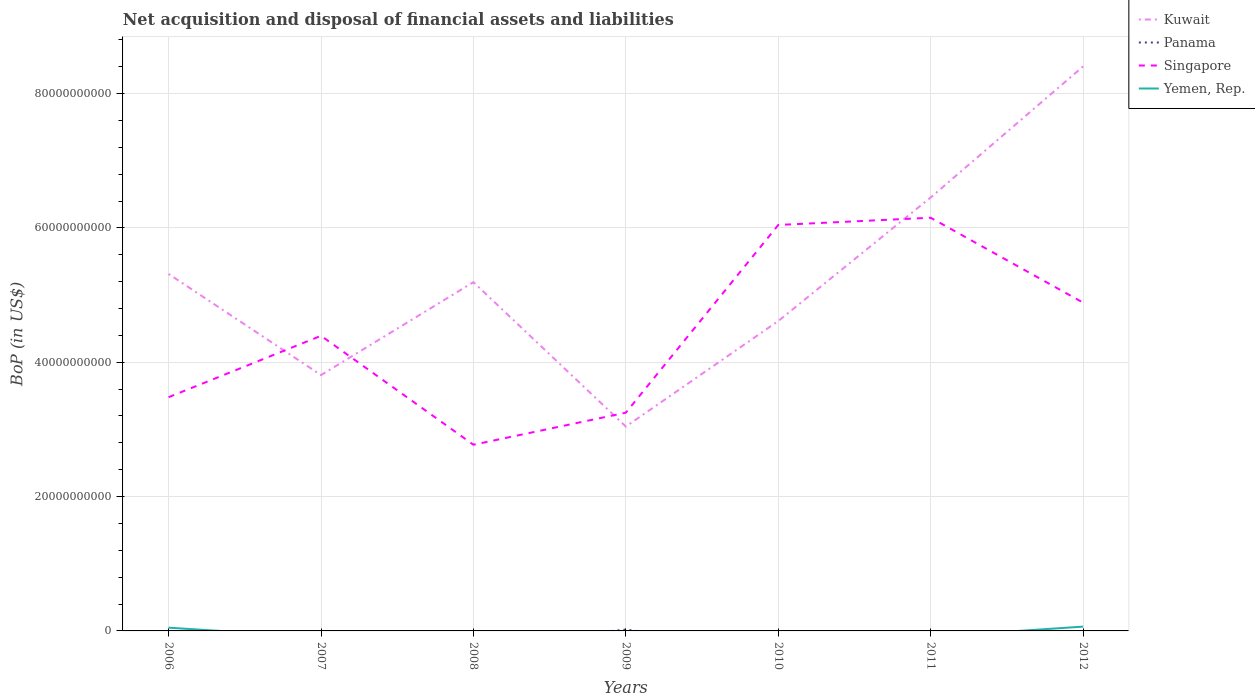How many different coloured lines are there?
Ensure brevity in your answer.  4. Does the line corresponding to Kuwait intersect with the line corresponding to Panama?
Your response must be concise. No. Across all years, what is the maximum Balance of Payments in Kuwait?
Provide a short and direct response. 3.04e+1. What is the total Balance of Payments in Kuwait in the graph?
Give a very brief answer. -3.21e+1. What is the difference between the highest and the second highest Balance of Payments in Yemen, Rep.?
Provide a succinct answer. 6.41e+08. How many lines are there?
Offer a terse response. 4. What is the difference between two consecutive major ticks on the Y-axis?
Ensure brevity in your answer.  2.00e+1. Are the values on the major ticks of Y-axis written in scientific E-notation?
Your answer should be compact. No. Does the graph contain any zero values?
Keep it short and to the point. Yes. What is the title of the graph?
Your answer should be compact. Net acquisition and disposal of financial assets and liabilities. Does "Ecuador" appear as one of the legend labels in the graph?
Ensure brevity in your answer.  No. What is the label or title of the Y-axis?
Provide a short and direct response. BoP (in US$). What is the BoP (in US$) in Kuwait in 2006?
Give a very brief answer. 5.31e+1. What is the BoP (in US$) of Panama in 2006?
Your answer should be compact. 0. What is the BoP (in US$) in Singapore in 2006?
Keep it short and to the point. 3.48e+1. What is the BoP (in US$) in Yemen, Rep. in 2006?
Offer a very short reply. 4.81e+08. What is the BoP (in US$) in Kuwait in 2007?
Your answer should be very brief. 3.81e+1. What is the BoP (in US$) of Singapore in 2007?
Provide a short and direct response. 4.39e+1. What is the BoP (in US$) in Yemen, Rep. in 2007?
Keep it short and to the point. 0. What is the BoP (in US$) of Kuwait in 2008?
Offer a very short reply. 5.19e+1. What is the BoP (in US$) of Singapore in 2008?
Give a very brief answer. 2.77e+1. What is the BoP (in US$) of Yemen, Rep. in 2008?
Offer a terse response. 0. What is the BoP (in US$) in Kuwait in 2009?
Keep it short and to the point. 3.04e+1. What is the BoP (in US$) in Panama in 2009?
Offer a very short reply. 2.02e+08. What is the BoP (in US$) in Singapore in 2009?
Provide a short and direct response. 3.25e+1. What is the BoP (in US$) of Yemen, Rep. in 2009?
Keep it short and to the point. 0. What is the BoP (in US$) in Kuwait in 2010?
Your answer should be very brief. 4.61e+1. What is the BoP (in US$) of Singapore in 2010?
Ensure brevity in your answer.  6.04e+1. What is the BoP (in US$) of Kuwait in 2011?
Your answer should be compact. 6.45e+1. What is the BoP (in US$) of Panama in 2011?
Make the answer very short. 0. What is the BoP (in US$) in Singapore in 2011?
Your response must be concise. 6.15e+1. What is the BoP (in US$) in Yemen, Rep. in 2011?
Offer a terse response. 0. What is the BoP (in US$) in Kuwait in 2012?
Keep it short and to the point. 8.40e+1. What is the BoP (in US$) in Panama in 2012?
Make the answer very short. 0. What is the BoP (in US$) of Singapore in 2012?
Ensure brevity in your answer.  4.89e+1. What is the BoP (in US$) in Yemen, Rep. in 2012?
Give a very brief answer. 6.41e+08. Across all years, what is the maximum BoP (in US$) of Kuwait?
Your answer should be compact. 8.40e+1. Across all years, what is the maximum BoP (in US$) in Panama?
Your response must be concise. 2.02e+08. Across all years, what is the maximum BoP (in US$) of Singapore?
Your answer should be compact. 6.15e+1. Across all years, what is the maximum BoP (in US$) in Yemen, Rep.?
Provide a short and direct response. 6.41e+08. Across all years, what is the minimum BoP (in US$) in Kuwait?
Offer a very short reply. 3.04e+1. Across all years, what is the minimum BoP (in US$) of Panama?
Ensure brevity in your answer.  0. Across all years, what is the minimum BoP (in US$) in Singapore?
Offer a very short reply. 2.77e+1. What is the total BoP (in US$) of Kuwait in the graph?
Your answer should be very brief. 3.68e+11. What is the total BoP (in US$) in Panama in the graph?
Make the answer very short. 2.02e+08. What is the total BoP (in US$) in Singapore in the graph?
Provide a succinct answer. 3.10e+11. What is the total BoP (in US$) of Yemen, Rep. in the graph?
Provide a succinct answer. 1.12e+09. What is the difference between the BoP (in US$) of Kuwait in 2006 and that in 2007?
Provide a succinct answer. 1.51e+1. What is the difference between the BoP (in US$) in Singapore in 2006 and that in 2007?
Offer a very short reply. -9.14e+09. What is the difference between the BoP (in US$) in Kuwait in 2006 and that in 2008?
Offer a terse response. 1.22e+09. What is the difference between the BoP (in US$) in Singapore in 2006 and that in 2008?
Your answer should be very brief. 7.08e+09. What is the difference between the BoP (in US$) of Kuwait in 2006 and that in 2009?
Your answer should be compact. 2.27e+1. What is the difference between the BoP (in US$) of Singapore in 2006 and that in 2009?
Provide a short and direct response. 2.31e+09. What is the difference between the BoP (in US$) of Kuwait in 2006 and that in 2010?
Offer a very short reply. 7.01e+09. What is the difference between the BoP (in US$) in Singapore in 2006 and that in 2010?
Provide a short and direct response. -2.56e+1. What is the difference between the BoP (in US$) in Kuwait in 2006 and that in 2011?
Provide a short and direct response. -1.14e+1. What is the difference between the BoP (in US$) in Singapore in 2006 and that in 2011?
Give a very brief answer. -2.67e+1. What is the difference between the BoP (in US$) of Kuwait in 2006 and that in 2012?
Provide a short and direct response. -3.09e+1. What is the difference between the BoP (in US$) of Singapore in 2006 and that in 2012?
Ensure brevity in your answer.  -1.41e+1. What is the difference between the BoP (in US$) in Yemen, Rep. in 2006 and that in 2012?
Your answer should be very brief. -1.59e+08. What is the difference between the BoP (in US$) of Kuwait in 2007 and that in 2008?
Your answer should be compact. -1.38e+1. What is the difference between the BoP (in US$) of Singapore in 2007 and that in 2008?
Your answer should be very brief. 1.62e+1. What is the difference between the BoP (in US$) in Kuwait in 2007 and that in 2009?
Provide a succinct answer. 7.66e+09. What is the difference between the BoP (in US$) in Singapore in 2007 and that in 2009?
Provide a succinct answer. 1.14e+1. What is the difference between the BoP (in US$) of Kuwait in 2007 and that in 2010?
Your answer should be compact. -8.05e+09. What is the difference between the BoP (in US$) of Singapore in 2007 and that in 2010?
Keep it short and to the point. -1.65e+1. What is the difference between the BoP (in US$) in Kuwait in 2007 and that in 2011?
Provide a succinct answer. -2.64e+1. What is the difference between the BoP (in US$) of Singapore in 2007 and that in 2011?
Make the answer very short. -1.76e+1. What is the difference between the BoP (in US$) in Kuwait in 2007 and that in 2012?
Offer a very short reply. -4.59e+1. What is the difference between the BoP (in US$) of Singapore in 2007 and that in 2012?
Offer a terse response. -4.94e+09. What is the difference between the BoP (in US$) of Kuwait in 2008 and that in 2009?
Make the answer very short. 2.15e+1. What is the difference between the BoP (in US$) of Singapore in 2008 and that in 2009?
Your answer should be very brief. -4.77e+09. What is the difference between the BoP (in US$) of Kuwait in 2008 and that in 2010?
Your response must be concise. 5.79e+09. What is the difference between the BoP (in US$) of Singapore in 2008 and that in 2010?
Your answer should be very brief. -3.27e+1. What is the difference between the BoP (in US$) of Kuwait in 2008 and that in 2011?
Provide a succinct answer. -1.26e+1. What is the difference between the BoP (in US$) in Singapore in 2008 and that in 2011?
Make the answer very short. -3.38e+1. What is the difference between the BoP (in US$) of Kuwait in 2008 and that in 2012?
Your answer should be compact. -3.21e+1. What is the difference between the BoP (in US$) in Singapore in 2008 and that in 2012?
Your answer should be compact. -2.12e+1. What is the difference between the BoP (in US$) in Kuwait in 2009 and that in 2010?
Provide a short and direct response. -1.57e+1. What is the difference between the BoP (in US$) of Singapore in 2009 and that in 2010?
Give a very brief answer. -2.79e+1. What is the difference between the BoP (in US$) of Kuwait in 2009 and that in 2011?
Your response must be concise. -3.41e+1. What is the difference between the BoP (in US$) in Singapore in 2009 and that in 2011?
Offer a very short reply. -2.90e+1. What is the difference between the BoP (in US$) in Kuwait in 2009 and that in 2012?
Offer a very short reply. -5.36e+1. What is the difference between the BoP (in US$) of Singapore in 2009 and that in 2012?
Keep it short and to the point. -1.64e+1. What is the difference between the BoP (in US$) of Kuwait in 2010 and that in 2011?
Provide a succinct answer. -1.84e+1. What is the difference between the BoP (in US$) of Singapore in 2010 and that in 2011?
Make the answer very short. -1.08e+09. What is the difference between the BoP (in US$) of Kuwait in 2010 and that in 2012?
Provide a short and direct response. -3.79e+1. What is the difference between the BoP (in US$) in Singapore in 2010 and that in 2012?
Provide a succinct answer. 1.16e+1. What is the difference between the BoP (in US$) of Kuwait in 2011 and that in 2012?
Provide a succinct answer. -1.95e+1. What is the difference between the BoP (in US$) of Singapore in 2011 and that in 2012?
Offer a very short reply. 1.26e+1. What is the difference between the BoP (in US$) of Kuwait in 2006 and the BoP (in US$) of Singapore in 2007?
Provide a succinct answer. 9.21e+09. What is the difference between the BoP (in US$) in Kuwait in 2006 and the BoP (in US$) in Singapore in 2008?
Offer a very short reply. 2.54e+1. What is the difference between the BoP (in US$) of Kuwait in 2006 and the BoP (in US$) of Panama in 2009?
Offer a terse response. 5.29e+1. What is the difference between the BoP (in US$) of Kuwait in 2006 and the BoP (in US$) of Singapore in 2009?
Your response must be concise. 2.07e+1. What is the difference between the BoP (in US$) in Kuwait in 2006 and the BoP (in US$) in Singapore in 2010?
Provide a succinct answer. -7.29e+09. What is the difference between the BoP (in US$) of Kuwait in 2006 and the BoP (in US$) of Singapore in 2011?
Provide a short and direct response. -8.37e+09. What is the difference between the BoP (in US$) of Kuwait in 2006 and the BoP (in US$) of Singapore in 2012?
Keep it short and to the point. 4.27e+09. What is the difference between the BoP (in US$) in Kuwait in 2006 and the BoP (in US$) in Yemen, Rep. in 2012?
Provide a short and direct response. 5.25e+1. What is the difference between the BoP (in US$) of Singapore in 2006 and the BoP (in US$) of Yemen, Rep. in 2012?
Give a very brief answer. 3.42e+1. What is the difference between the BoP (in US$) in Kuwait in 2007 and the BoP (in US$) in Singapore in 2008?
Offer a very short reply. 1.04e+1. What is the difference between the BoP (in US$) in Kuwait in 2007 and the BoP (in US$) in Panama in 2009?
Your response must be concise. 3.79e+1. What is the difference between the BoP (in US$) of Kuwait in 2007 and the BoP (in US$) of Singapore in 2009?
Provide a succinct answer. 5.60e+09. What is the difference between the BoP (in US$) of Kuwait in 2007 and the BoP (in US$) of Singapore in 2010?
Give a very brief answer. -2.23e+1. What is the difference between the BoP (in US$) of Kuwait in 2007 and the BoP (in US$) of Singapore in 2011?
Make the answer very short. -2.34e+1. What is the difference between the BoP (in US$) in Kuwait in 2007 and the BoP (in US$) in Singapore in 2012?
Give a very brief answer. -1.08e+1. What is the difference between the BoP (in US$) of Kuwait in 2007 and the BoP (in US$) of Yemen, Rep. in 2012?
Your answer should be very brief. 3.74e+1. What is the difference between the BoP (in US$) of Singapore in 2007 and the BoP (in US$) of Yemen, Rep. in 2012?
Offer a terse response. 4.33e+1. What is the difference between the BoP (in US$) in Kuwait in 2008 and the BoP (in US$) in Panama in 2009?
Give a very brief answer. 5.17e+1. What is the difference between the BoP (in US$) in Kuwait in 2008 and the BoP (in US$) in Singapore in 2009?
Give a very brief answer. 1.94e+1. What is the difference between the BoP (in US$) of Kuwait in 2008 and the BoP (in US$) of Singapore in 2010?
Offer a terse response. -8.51e+09. What is the difference between the BoP (in US$) of Kuwait in 2008 and the BoP (in US$) of Singapore in 2011?
Your response must be concise. -9.59e+09. What is the difference between the BoP (in US$) in Kuwait in 2008 and the BoP (in US$) in Singapore in 2012?
Provide a short and direct response. 3.05e+09. What is the difference between the BoP (in US$) in Kuwait in 2008 and the BoP (in US$) in Yemen, Rep. in 2012?
Keep it short and to the point. 5.13e+1. What is the difference between the BoP (in US$) in Singapore in 2008 and the BoP (in US$) in Yemen, Rep. in 2012?
Provide a short and direct response. 2.71e+1. What is the difference between the BoP (in US$) of Kuwait in 2009 and the BoP (in US$) of Singapore in 2010?
Provide a succinct answer. -3.00e+1. What is the difference between the BoP (in US$) in Panama in 2009 and the BoP (in US$) in Singapore in 2010?
Keep it short and to the point. -6.02e+1. What is the difference between the BoP (in US$) of Kuwait in 2009 and the BoP (in US$) of Singapore in 2011?
Your response must be concise. -3.11e+1. What is the difference between the BoP (in US$) of Panama in 2009 and the BoP (in US$) of Singapore in 2011?
Your response must be concise. -6.13e+1. What is the difference between the BoP (in US$) of Kuwait in 2009 and the BoP (in US$) of Singapore in 2012?
Give a very brief answer. -1.84e+1. What is the difference between the BoP (in US$) in Kuwait in 2009 and the BoP (in US$) in Yemen, Rep. in 2012?
Ensure brevity in your answer.  2.98e+1. What is the difference between the BoP (in US$) in Panama in 2009 and the BoP (in US$) in Singapore in 2012?
Ensure brevity in your answer.  -4.87e+1. What is the difference between the BoP (in US$) in Panama in 2009 and the BoP (in US$) in Yemen, Rep. in 2012?
Give a very brief answer. -4.39e+08. What is the difference between the BoP (in US$) in Singapore in 2009 and the BoP (in US$) in Yemen, Rep. in 2012?
Keep it short and to the point. 3.18e+1. What is the difference between the BoP (in US$) in Kuwait in 2010 and the BoP (in US$) in Singapore in 2011?
Offer a very short reply. -1.54e+1. What is the difference between the BoP (in US$) of Kuwait in 2010 and the BoP (in US$) of Singapore in 2012?
Keep it short and to the point. -2.74e+09. What is the difference between the BoP (in US$) in Kuwait in 2010 and the BoP (in US$) in Yemen, Rep. in 2012?
Your response must be concise. 4.55e+1. What is the difference between the BoP (in US$) of Singapore in 2010 and the BoP (in US$) of Yemen, Rep. in 2012?
Offer a terse response. 5.98e+1. What is the difference between the BoP (in US$) of Kuwait in 2011 and the BoP (in US$) of Singapore in 2012?
Your answer should be compact. 1.57e+1. What is the difference between the BoP (in US$) in Kuwait in 2011 and the BoP (in US$) in Yemen, Rep. in 2012?
Provide a short and direct response. 6.39e+1. What is the difference between the BoP (in US$) of Singapore in 2011 and the BoP (in US$) of Yemen, Rep. in 2012?
Provide a succinct answer. 6.09e+1. What is the average BoP (in US$) of Kuwait per year?
Offer a very short reply. 5.26e+1. What is the average BoP (in US$) in Panama per year?
Offer a terse response. 2.88e+07. What is the average BoP (in US$) of Singapore per year?
Provide a succinct answer. 4.42e+1. What is the average BoP (in US$) in Yemen, Rep. per year?
Ensure brevity in your answer.  1.60e+08. In the year 2006, what is the difference between the BoP (in US$) in Kuwait and BoP (in US$) in Singapore?
Your answer should be very brief. 1.83e+1. In the year 2006, what is the difference between the BoP (in US$) in Kuwait and BoP (in US$) in Yemen, Rep.?
Your answer should be very brief. 5.27e+1. In the year 2006, what is the difference between the BoP (in US$) in Singapore and BoP (in US$) in Yemen, Rep.?
Your answer should be very brief. 3.43e+1. In the year 2007, what is the difference between the BoP (in US$) of Kuwait and BoP (in US$) of Singapore?
Your answer should be very brief. -5.85e+09. In the year 2008, what is the difference between the BoP (in US$) in Kuwait and BoP (in US$) in Singapore?
Your answer should be compact. 2.42e+1. In the year 2009, what is the difference between the BoP (in US$) in Kuwait and BoP (in US$) in Panama?
Give a very brief answer. 3.02e+1. In the year 2009, what is the difference between the BoP (in US$) of Kuwait and BoP (in US$) of Singapore?
Provide a succinct answer. -2.06e+09. In the year 2009, what is the difference between the BoP (in US$) of Panama and BoP (in US$) of Singapore?
Your answer should be very brief. -3.23e+1. In the year 2010, what is the difference between the BoP (in US$) in Kuwait and BoP (in US$) in Singapore?
Make the answer very short. -1.43e+1. In the year 2011, what is the difference between the BoP (in US$) of Kuwait and BoP (in US$) of Singapore?
Offer a very short reply. 3.02e+09. In the year 2012, what is the difference between the BoP (in US$) in Kuwait and BoP (in US$) in Singapore?
Make the answer very short. 3.52e+1. In the year 2012, what is the difference between the BoP (in US$) in Kuwait and BoP (in US$) in Yemen, Rep.?
Offer a terse response. 8.34e+1. In the year 2012, what is the difference between the BoP (in US$) in Singapore and BoP (in US$) in Yemen, Rep.?
Provide a succinct answer. 4.82e+1. What is the ratio of the BoP (in US$) in Kuwait in 2006 to that in 2007?
Offer a terse response. 1.4. What is the ratio of the BoP (in US$) of Singapore in 2006 to that in 2007?
Offer a very short reply. 0.79. What is the ratio of the BoP (in US$) of Kuwait in 2006 to that in 2008?
Your response must be concise. 1.02. What is the ratio of the BoP (in US$) of Singapore in 2006 to that in 2008?
Your answer should be very brief. 1.26. What is the ratio of the BoP (in US$) in Kuwait in 2006 to that in 2009?
Keep it short and to the point. 1.75. What is the ratio of the BoP (in US$) of Singapore in 2006 to that in 2009?
Your answer should be very brief. 1.07. What is the ratio of the BoP (in US$) in Kuwait in 2006 to that in 2010?
Your answer should be compact. 1.15. What is the ratio of the BoP (in US$) in Singapore in 2006 to that in 2010?
Offer a terse response. 0.58. What is the ratio of the BoP (in US$) in Kuwait in 2006 to that in 2011?
Your answer should be compact. 0.82. What is the ratio of the BoP (in US$) in Singapore in 2006 to that in 2011?
Offer a very short reply. 0.57. What is the ratio of the BoP (in US$) of Kuwait in 2006 to that in 2012?
Offer a very short reply. 0.63. What is the ratio of the BoP (in US$) in Singapore in 2006 to that in 2012?
Your response must be concise. 0.71. What is the ratio of the BoP (in US$) in Yemen, Rep. in 2006 to that in 2012?
Provide a succinct answer. 0.75. What is the ratio of the BoP (in US$) of Kuwait in 2007 to that in 2008?
Ensure brevity in your answer.  0.73. What is the ratio of the BoP (in US$) of Singapore in 2007 to that in 2008?
Provide a short and direct response. 1.59. What is the ratio of the BoP (in US$) in Kuwait in 2007 to that in 2009?
Make the answer very short. 1.25. What is the ratio of the BoP (in US$) in Singapore in 2007 to that in 2009?
Your answer should be very brief. 1.35. What is the ratio of the BoP (in US$) in Kuwait in 2007 to that in 2010?
Your response must be concise. 0.83. What is the ratio of the BoP (in US$) of Singapore in 2007 to that in 2010?
Your response must be concise. 0.73. What is the ratio of the BoP (in US$) in Kuwait in 2007 to that in 2011?
Provide a short and direct response. 0.59. What is the ratio of the BoP (in US$) in Singapore in 2007 to that in 2011?
Your answer should be compact. 0.71. What is the ratio of the BoP (in US$) of Kuwait in 2007 to that in 2012?
Your answer should be compact. 0.45. What is the ratio of the BoP (in US$) in Singapore in 2007 to that in 2012?
Your answer should be compact. 0.9. What is the ratio of the BoP (in US$) of Kuwait in 2008 to that in 2009?
Your answer should be very brief. 1.71. What is the ratio of the BoP (in US$) in Singapore in 2008 to that in 2009?
Provide a short and direct response. 0.85. What is the ratio of the BoP (in US$) in Kuwait in 2008 to that in 2010?
Your response must be concise. 1.13. What is the ratio of the BoP (in US$) of Singapore in 2008 to that in 2010?
Offer a very short reply. 0.46. What is the ratio of the BoP (in US$) of Kuwait in 2008 to that in 2011?
Offer a very short reply. 0.8. What is the ratio of the BoP (in US$) of Singapore in 2008 to that in 2011?
Offer a very short reply. 0.45. What is the ratio of the BoP (in US$) in Kuwait in 2008 to that in 2012?
Your response must be concise. 0.62. What is the ratio of the BoP (in US$) in Singapore in 2008 to that in 2012?
Ensure brevity in your answer.  0.57. What is the ratio of the BoP (in US$) in Kuwait in 2009 to that in 2010?
Offer a very short reply. 0.66. What is the ratio of the BoP (in US$) of Singapore in 2009 to that in 2010?
Ensure brevity in your answer.  0.54. What is the ratio of the BoP (in US$) in Kuwait in 2009 to that in 2011?
Offer a very short reply. 0.47. What is the ratio of the BoP (in US$) in Singapore in 2009 to that in 2011?
Offer a terse response. 0.53. What is the ratio of the BoP (in US$) of Kuwait in 2009 to that in 2012?
Ensure brevity in your answer.  0.36. What is the ratio of the BoP (in US$) of Singapore in 2009 to that in 2012?
Your answer should be very brief. 0.66. What is the ratio of the BoP (in US$) of Kuwait in 2010 to that in 2011?
Make the answer very short. 0.71. What is the ratio of the BoP (in US$) of Singapore in 2010 to that in 2011?
Keep it short and to the point. 0.98. What is the ratio of the BoP (in US$) in Kuwait in 2010 to that in 2012?
Your response must be concise. 0.55. What is the ratio of the BoP (in US$) of Singapore in 2010 to that in 2012?
Make the answer very short. 1.24. What is the ratio of the BoP (in US$) of Kuwait in 2011 to that in 2012?
Offer a very short reply. 0.77. What is the ratio of the BoP (in US$) of Singapore in 2011 to that in 2012?
Offer a very short reply. 1.26. What is the difference between the highest and the second highest BoP (in US$) of Kuwait?
Provide a succinct answer. 1.95e+1. What is the difference between the highest and the second highest BoP (in US$) in Singapore?
Provide a succinct answer. 1.08e+09. What is the difference between the highest and the lowest BoP (in US$) in Kuwait?
Give a very brief answer. 5.36e+1. What is the difference between the highest and the lowest BoP (in US$) of Panama?
Offer a very short reply. 2.02e+08. What is the difference between the highest and the lowest BoP (in US$) of Singapore?
Keep it short and to the point. 3.38e+1. What is the difference between the highest and the lowest BoP (in US$) in Yemen, Rep.?
Offer a very short reply. 6.41e+08. 